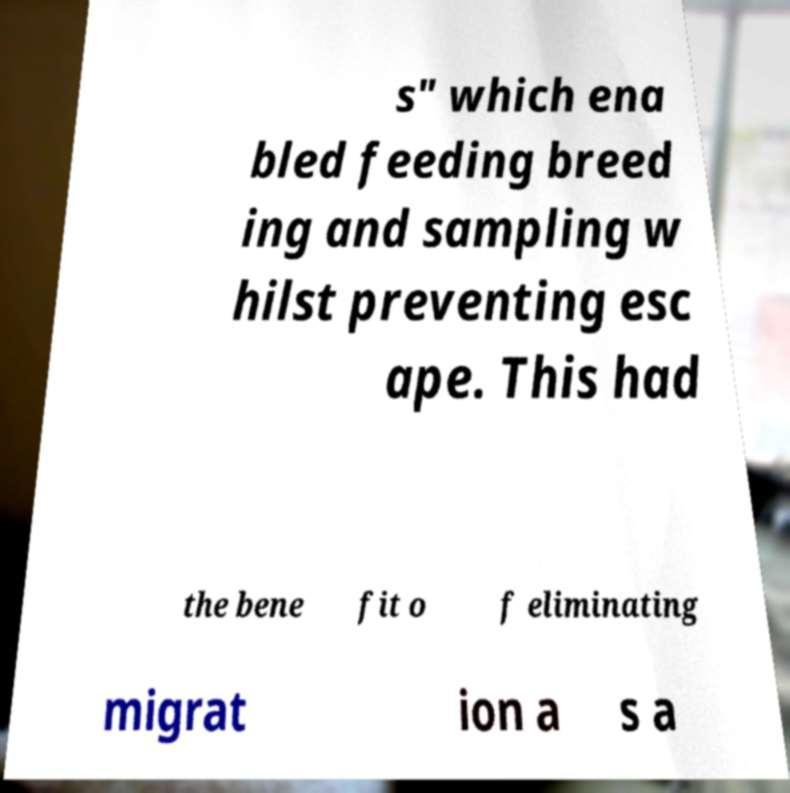Can you accurately transcribe the text from the provided image for me? s" which ena bled feeding breed ing and sampling w hilst preventing esc ape. This had the bene fit o f eliminating migrat ion a s a 